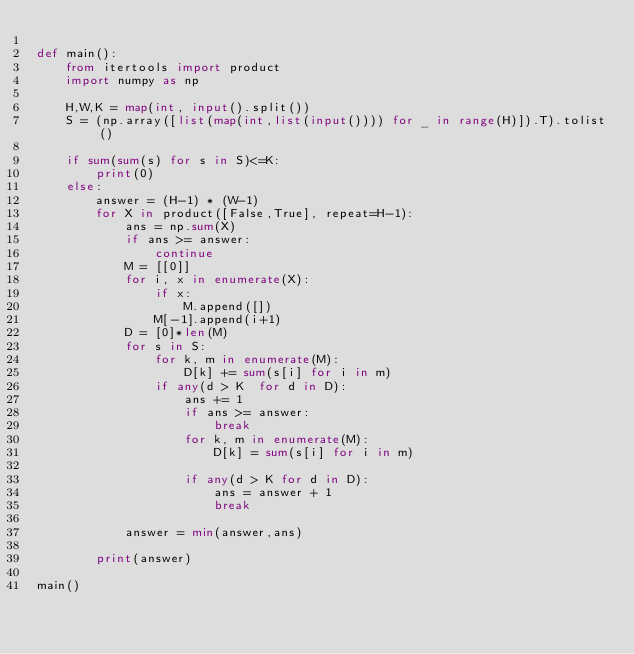Convert code to text. <code><loc_0><loc_0><loc_500><loc_500><_Python_>
def main():
    from itertools import product
    import numpy as np

    H,W,K = map(int, input().split())
    S = (np.array([list(map(int,list(input()))) for _ in range(H)]).T).tolist()

    if sum(sum(s) for s in S)<=K:
        print(0)
    else:
        answer = (H-1) * (W-1)
        for X in product([False,True], repeat=H-1):
            ans = np.sum(X)
            if ans >= answer:
                continue
            M = [[0]]
            for i, x in enumerate(X):
                if x:
                    M.append([])
                M[-1].append(i+1)
            D = [0]*len(M)
            for s in S:
                for k, m in enumerate(M):
                    D[k] += sum(s[i] for i in m)
                if any(d > K  for d in D):
                    ans += 1
                    if ans >= answer:
                        break
                    for k, m in enumerate(M):
                        D[k] = sum(s[i] for i in m)
                    
                    if any(d > K for d in D):
                        ans = answer + 1
                        break

            answer = min(answer,ans)

        print(answer)

main()</code> 